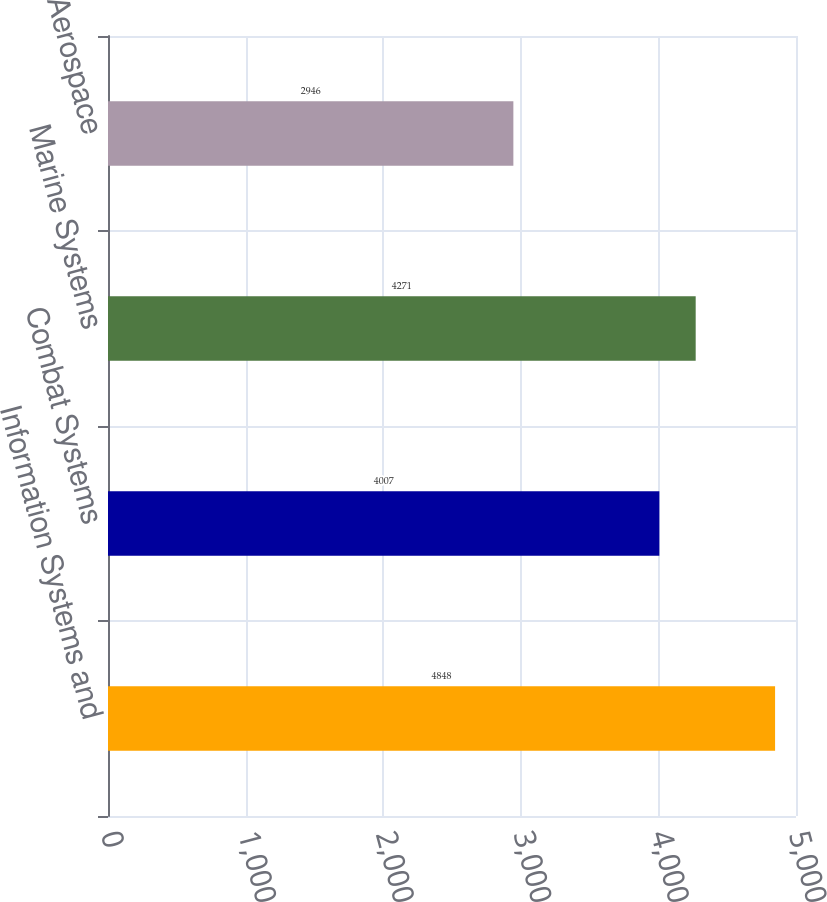Convert chart to OTSL. <chart><loc_0><loc_0><loc_500><loc_500><bar_chart><fcel>Information Systems and<fcel>Combat Systems<fcel>Marine Systems<fcel>Aerospace<nl><fcel>4848<fcel>4007<fcel>4271<fcel>2946<nl></chart> 